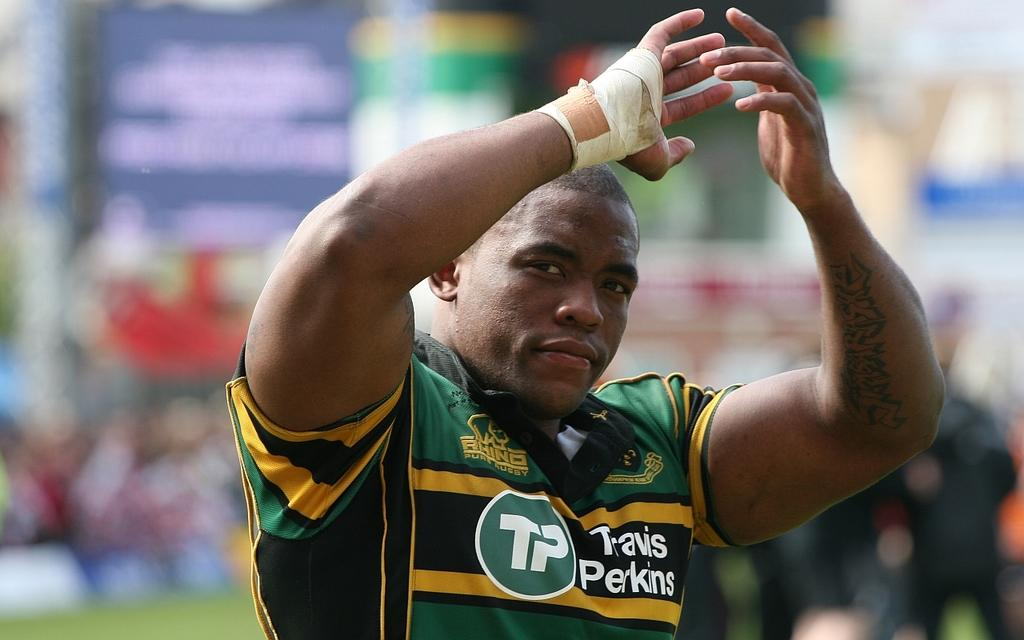Provide a one-sentence caption for the provided image. A sports athlete with the name Travis Perkins written on his jersey. 